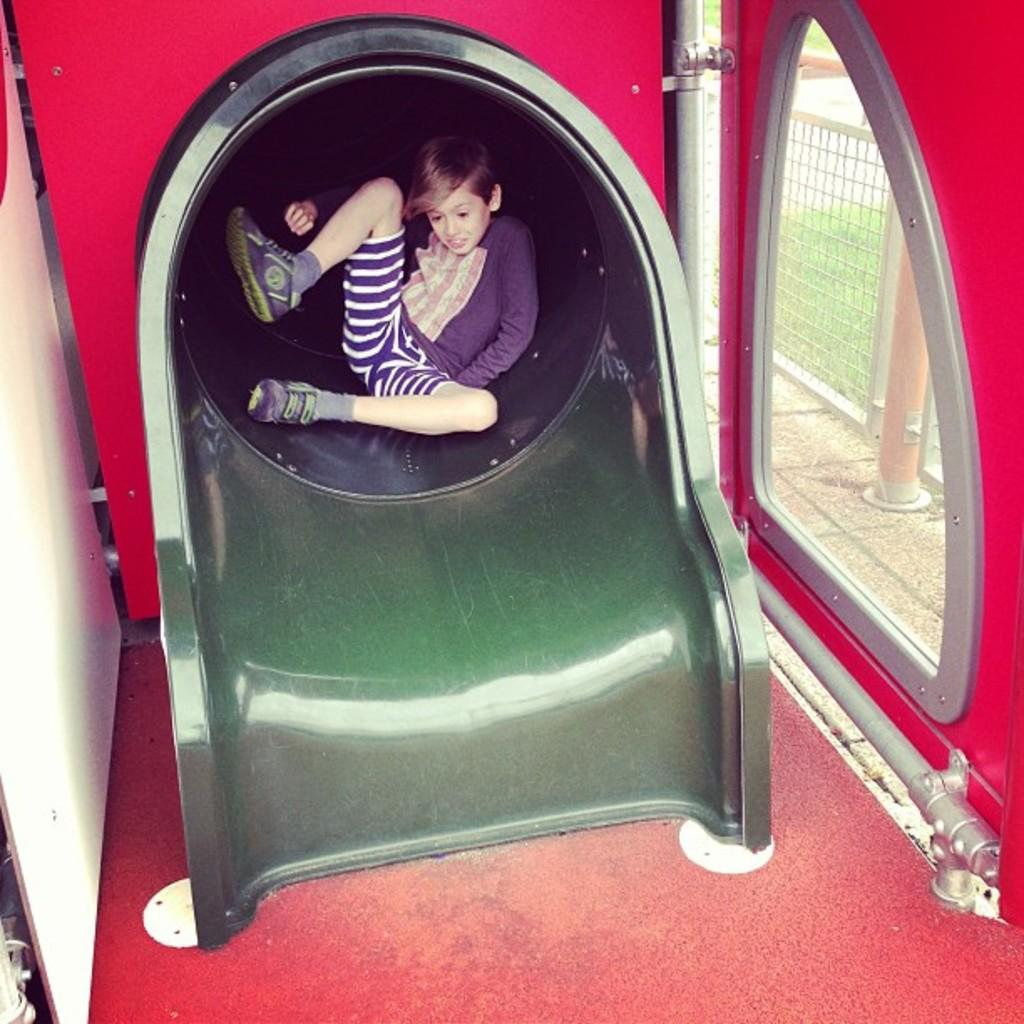What is the child doing in the image? The child is sitting on a slide. What can be seen through the window in the image? Grass and a fence are visible through the window. What other objects are present in the image? There is a window, a pipe, and a fence visible in the image. What rule is being enforced by the child in the image? There is no indication in the image that the child is enforcing any rules. 